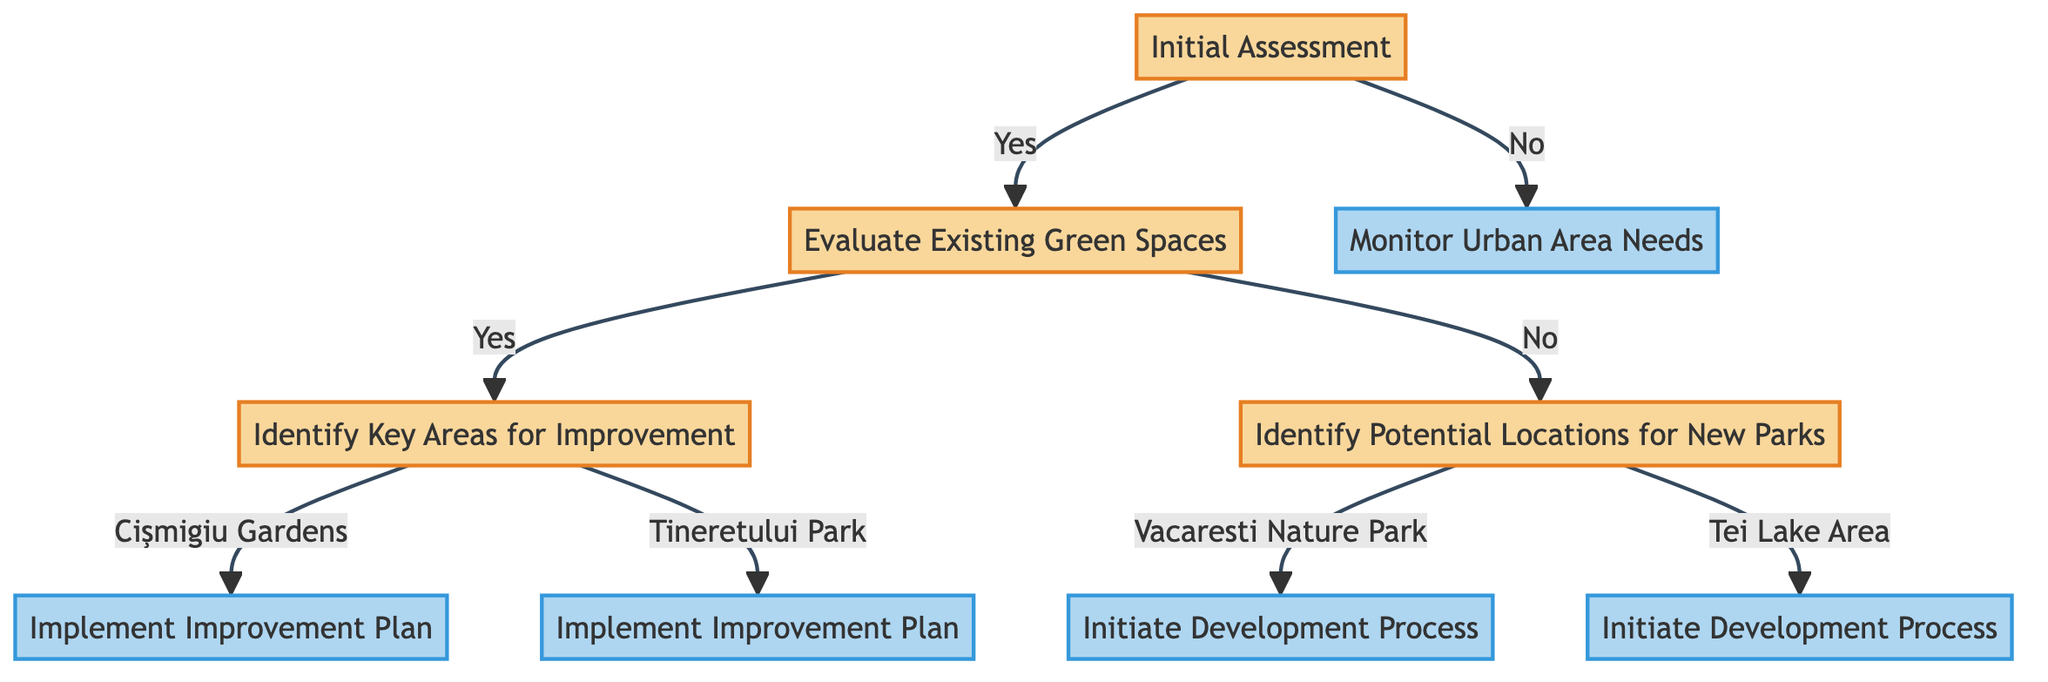What is the first decision in this diagram? The first decision node is "Initial Assessment", which asks, "Is this urban area in need of green space development?" This sets the stage for the entire process depicted in the diagram.
Answer: Initial Assessment How many potential locations for new parks are identified? The diagram indicates two potential locations for new parks: "Vacaresti Nature Park" and "Tei Lake Area". This information is located within the decision path that comes into play when existing parks do not require improvement.
Answer: 2 If the answer to "Is this urban area in need of green space development?" is "No", what is the next action step? If the answer is "No", the next action specified is "Monitor Urban Area Needs". This follows the willful decision not to develop green spaces due to the current sufficiency of existing areas.
Answer: Monitor Urban Area Needs Which two parks are identified for improvement? The two parks identified for improvement are "Cişmigiu Gardens" and "Tineretului Park". These are specified in the branch that answers "Yes" to the evaluation of existing green spaces needing improvement.
Answer: Cişmigiu Gardens, Tineretului Park What action is initiated for "Vacaresti Nature Park"? For "Vacaresti Nature Park", the action initiated is "Initiate Development Process". This is part of the flow determined when there are no existing parks that need improvement and a need for new parks is identified.
Answer: Initiate Development Process What is the outcome if "Yes" is answered to "Are there existing parks that need improvement?" If "Yes" is answered, the process leads to "Identify Key Areas for Improvement". From there, the diagram specifies which parks are prioritized for improvement, taking us directly into implementation.
Answer: Identify Key Areas for Improvement What type of nodes are "Implement Improvement Plan" and "Initiate Development Process"? Both "Implement Improvement Plan" and "Initiate Development Process" are classified as action nodes. These nodes represent the concrete steps that follow decisions made in the preceding evaluation stages.
Answer: Action How does the decision tree start evaluating green space needs? The evaluation begins with the decision node "Initial Assessment" which asks whether the urban area needs green space development. It's the critical starting point that guides the flow of the decision-making process.
Answer: Initial Assessment 